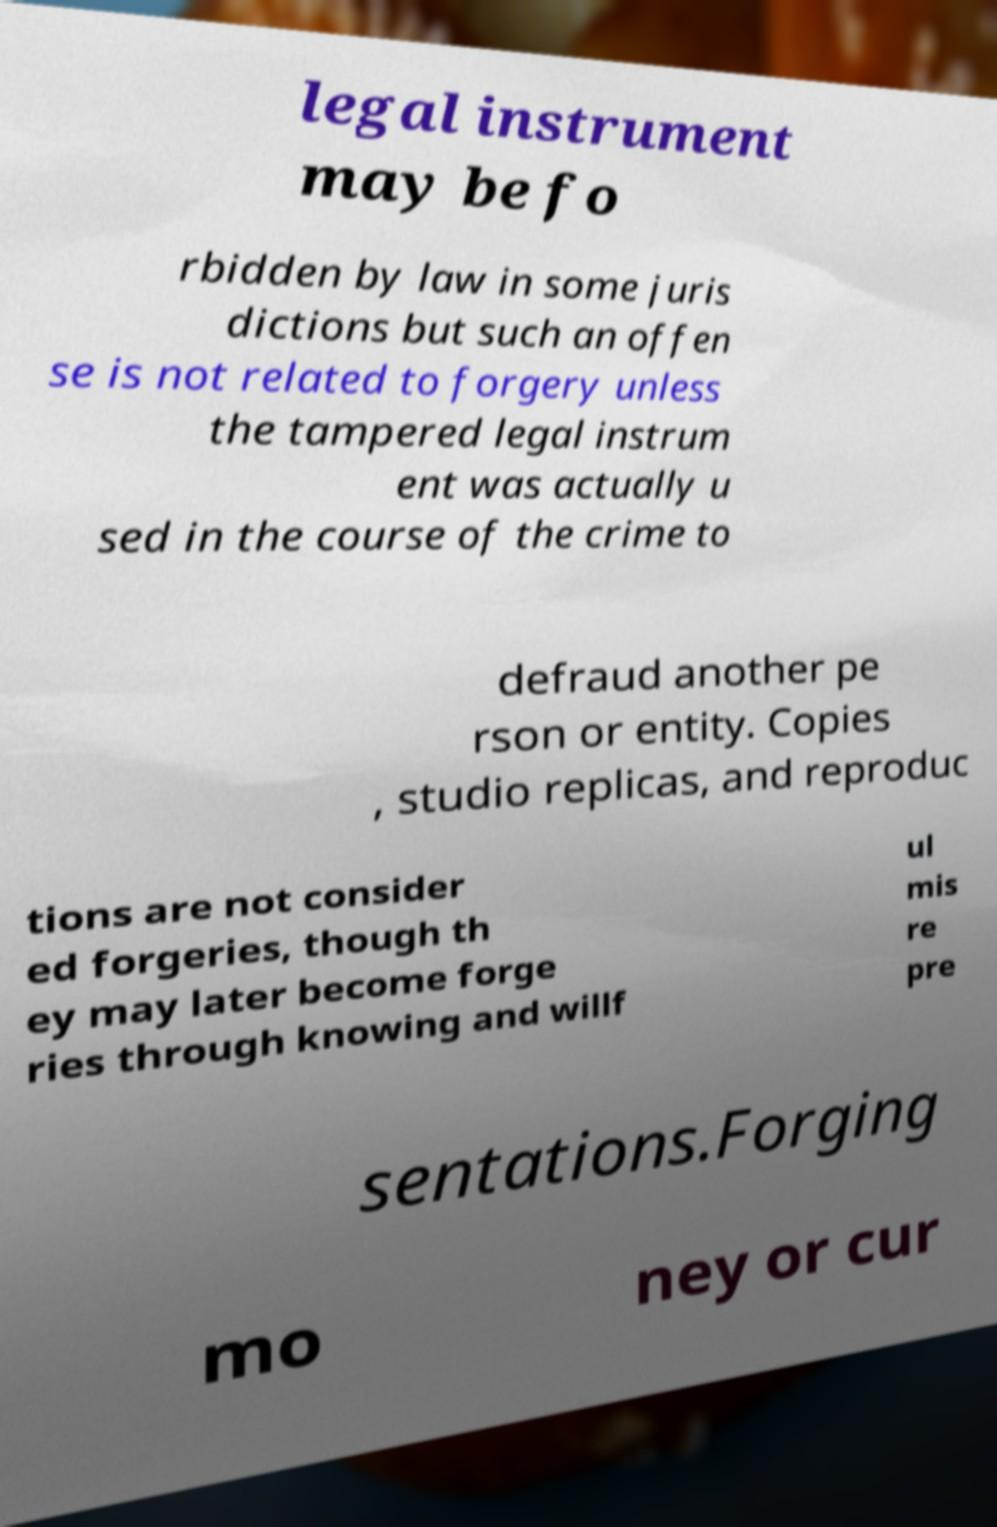Please read and relay the text visible in this image. What does it say? legal instrument may be fo rbidden by law in some juris dictions but such an offen se is not related to forgery unless the tampered legal instrum ent was actually u sed in the course of the crime to defraud another pe rson or entity. Copies , studio replicas, and reproduc tions are not consider ed forgeries, though th ey may later become forge ries through knowing and willf ul mis re pre sentations.Forging mo ney or cur 